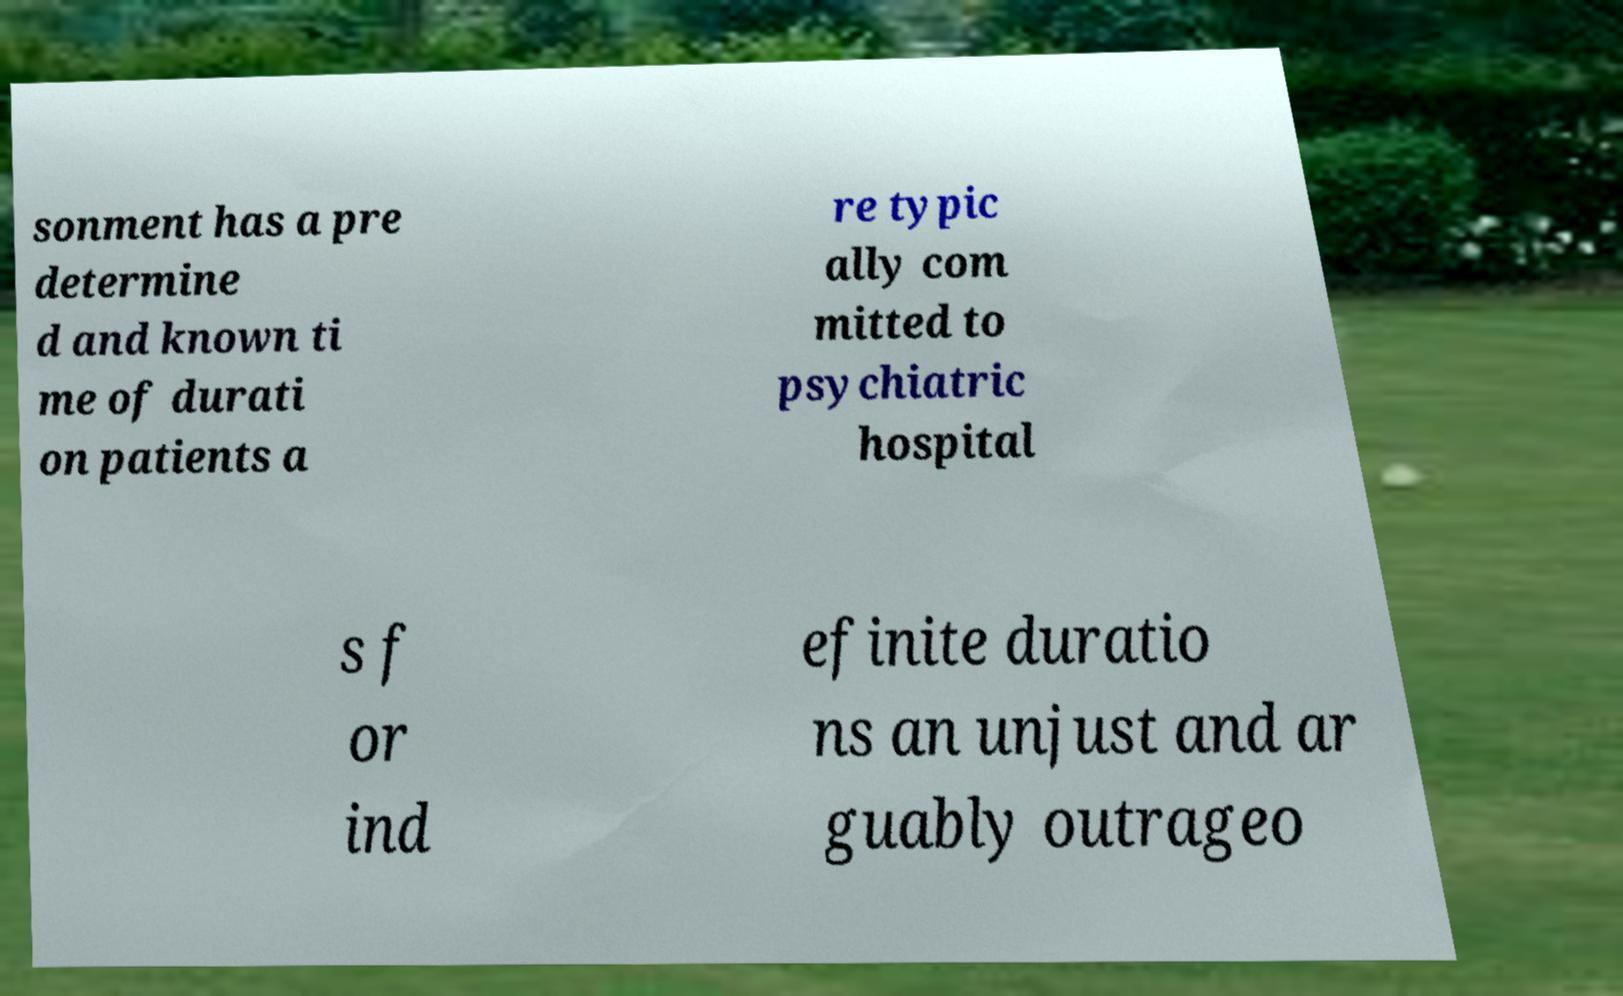Could you extract and type out the text from this image? sonment has a pre determine d and known ti me of durati on patients a re typic ally com mitted to psychiatric hospital s f or ind efinite duratio ns an unjust and ar guably outrageo 